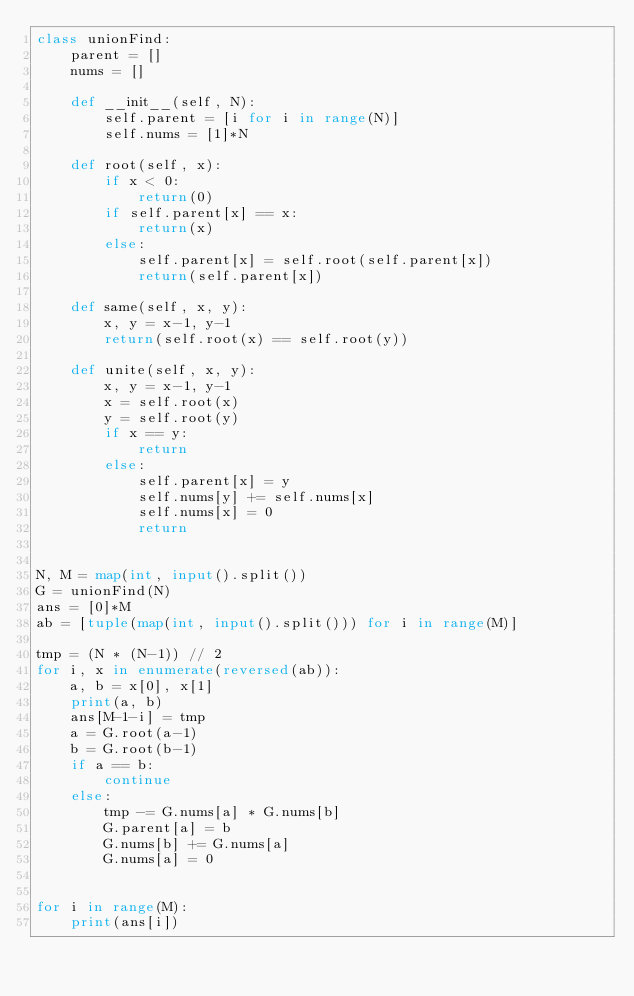Convert code to text. <code><loc_0><loc_0><loc_500><loc_500><_Python_>class unionFind:
    parent = []
    nums = []

    def __init__(self, N):
        self.parent = [i for i in range(N)]
        self.nums = [1]*N

    def root(self, x):
        if x < 0:
            return(0)
        if self.parent[x] == x:
            return(x)
        else:
            self.parent[x] = self.root(self.parent[x])
            return(self.parent[x])

    def same(self, x, y):
        x, y = x-1, y-1
        return(self.root(x) == self.root(y))

    def unite(self, x, y):
        x, y = x-1, y-1
        x = self.root(x)
        y = self.root(y)
        if x == y:
            return
        else:
            self.parent[x] = y
            self.nums[y] += self.nums[x]
            self.nums[x] = 0
            return


N, M = map(int, input().split())
G = unionFind(N)
ans = [0]*M
ab = [tuple(map(int, input().split())) for i in range(M)]

tmp = (N * (N-1)) // 2
for i, x in enumerate(reversed(ab)):
    a, b = x[0], x[1]
    print(a, b)
    ans[M-1-i] = tmp
    a = G.root(a-1)
    b = G.root(b-1)
    if a == b:
        continue
    else:
        tmp -= G.nums[a] * G.nums[b]
        G.parent[a] = b
        G.nums[b] += G.nums[a]
        G.nums[a] = 0


for i in range(M):
    print(ans[i])
</code> 